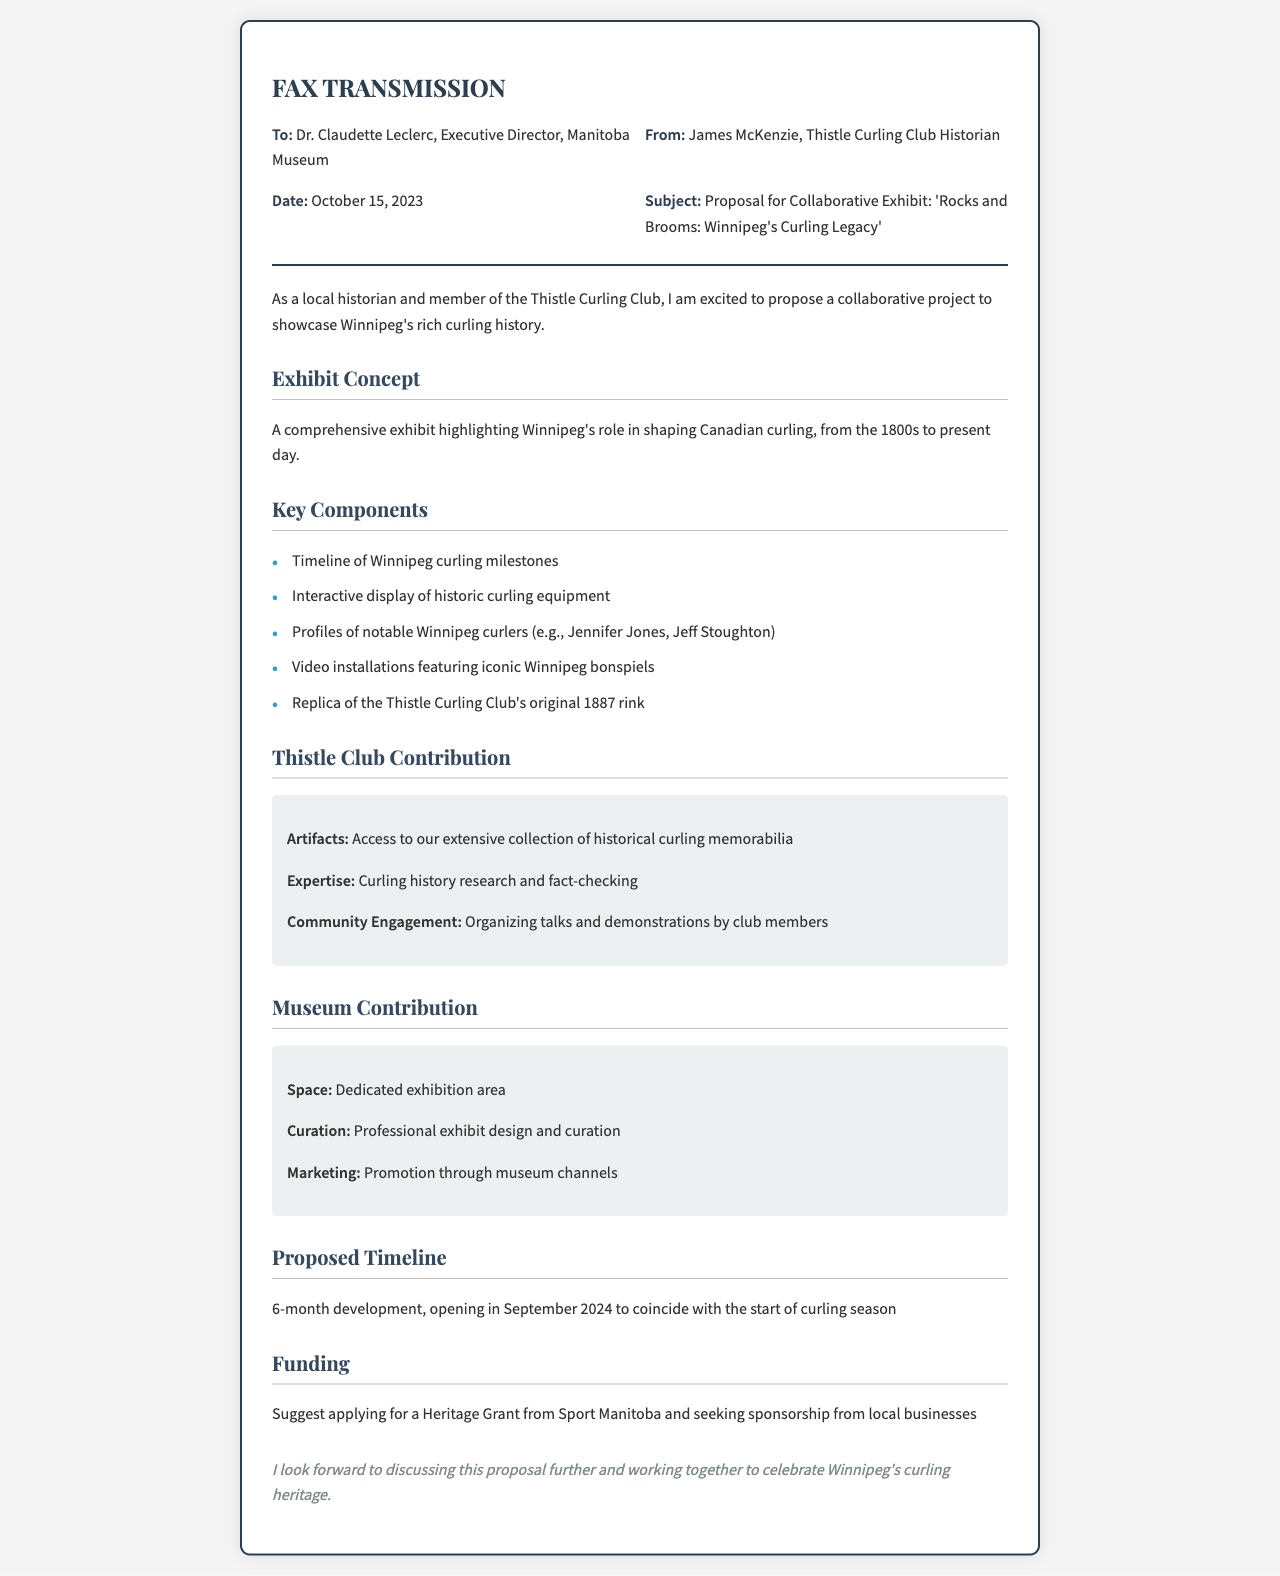What is the proposal title? The title of the proposal is stated in the subject line of the fax.
Answer: Rocks and Brooms: Winnipeg's Curling Legacy Who is the sender of the fax? The sender is identified in the 'From' section of the fax.
Answer: James McKenzie What is the proposed timeline for the exhibit? The proposed timeline is mentioned in the section on the proposed timeline.
Answer: 6-month development, opening in September 2024 What does the Thistle Curling Club contribute? The contributions of the Thistle Curling Club are outlined in the respective section of the fax.
Answer: Access to our extensive collection of historical curling memorabilia, curling history research and fact-checking, organizing talks and demonstrations by club members What is the suggested funding source? The funding sources are mentioned in the funding section of the fax.
Answer: Heritage Grant from Sport Manitoba What is one key component of the exhibit? Key components are listed in the section detailing the exhibit components.
Answer: Timeline of Winnipeg curling milestones What date was the fax sent? The date of the fax can be found in the header section.
Answer: October 15, 2023 Who is the recipient of the fax? The recipient is specified in the 'To' section of the fax.
Answer: Dr. Claudette Leclerc, Executive Director, Manitoba Museum What is one aspect of the Museum's contribution? The contributions of the museum are listed in the respective section of the fax.
Answer: Dedicated exhibition area 